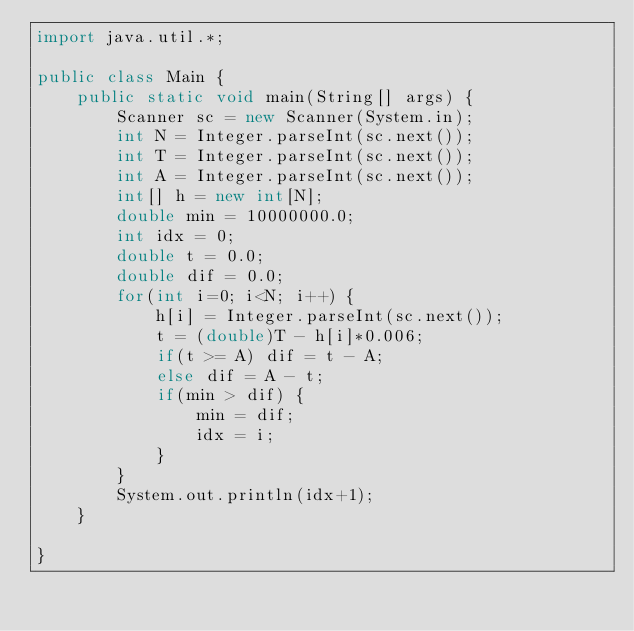Convert code to text. <code><loc_0><loc_0><loc_500><loc_500><_Java_>import java.util.*;
 
public class Main {
    public static void main(String[] args) {
        Scanner sc = new Scanner(System.in);
        int N = Integer.parseInt(sc.next());
        int T = Integer.parseInt(sc.next());
        int A = Integer.parseInt(sc.next());
        int[] h = new int[N];
        double min = 10000000.0;
        int idx = 0;
        double t = 0.0;
        double dif = 0.0;
        for(int i=0; i<N; i++) {
            h[i] = Integer.parseInt(sc.next());
            t = (double)T - h[i]*0.006;
            if(t >= A) dif = t - A;
            else dif = A - t;
            if(min > dif) {
                min = dif;
                idx = i;
            }
        }
        System.out.println(idx+1);
    }
    
}</code> 